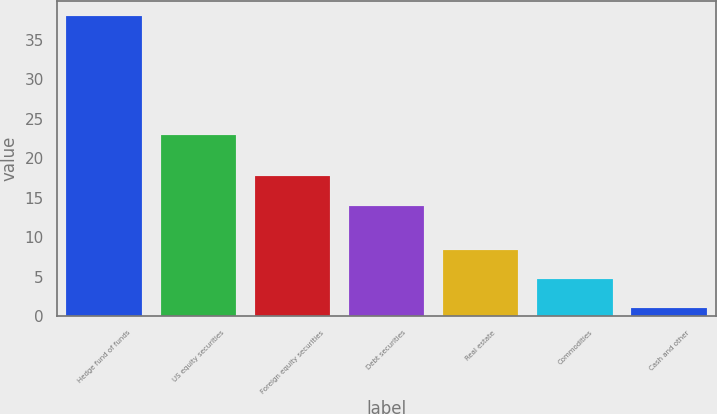Convert chart. <chart><loc_0><loc_0><loc_500><loc_500><bar_chart><fcel>Hedge fund of funds<fcel>US equity securities<fcel>Foreign equity securities<fcel>Debt securities<fcel>Real estate<fcel>Commodities<fcel>Cash and other<nl><fcel>38<fcel>23<fcel>17.7<fcel>14<fcel>8.4<fcel>4.7<fcel>1<nl></chart> 